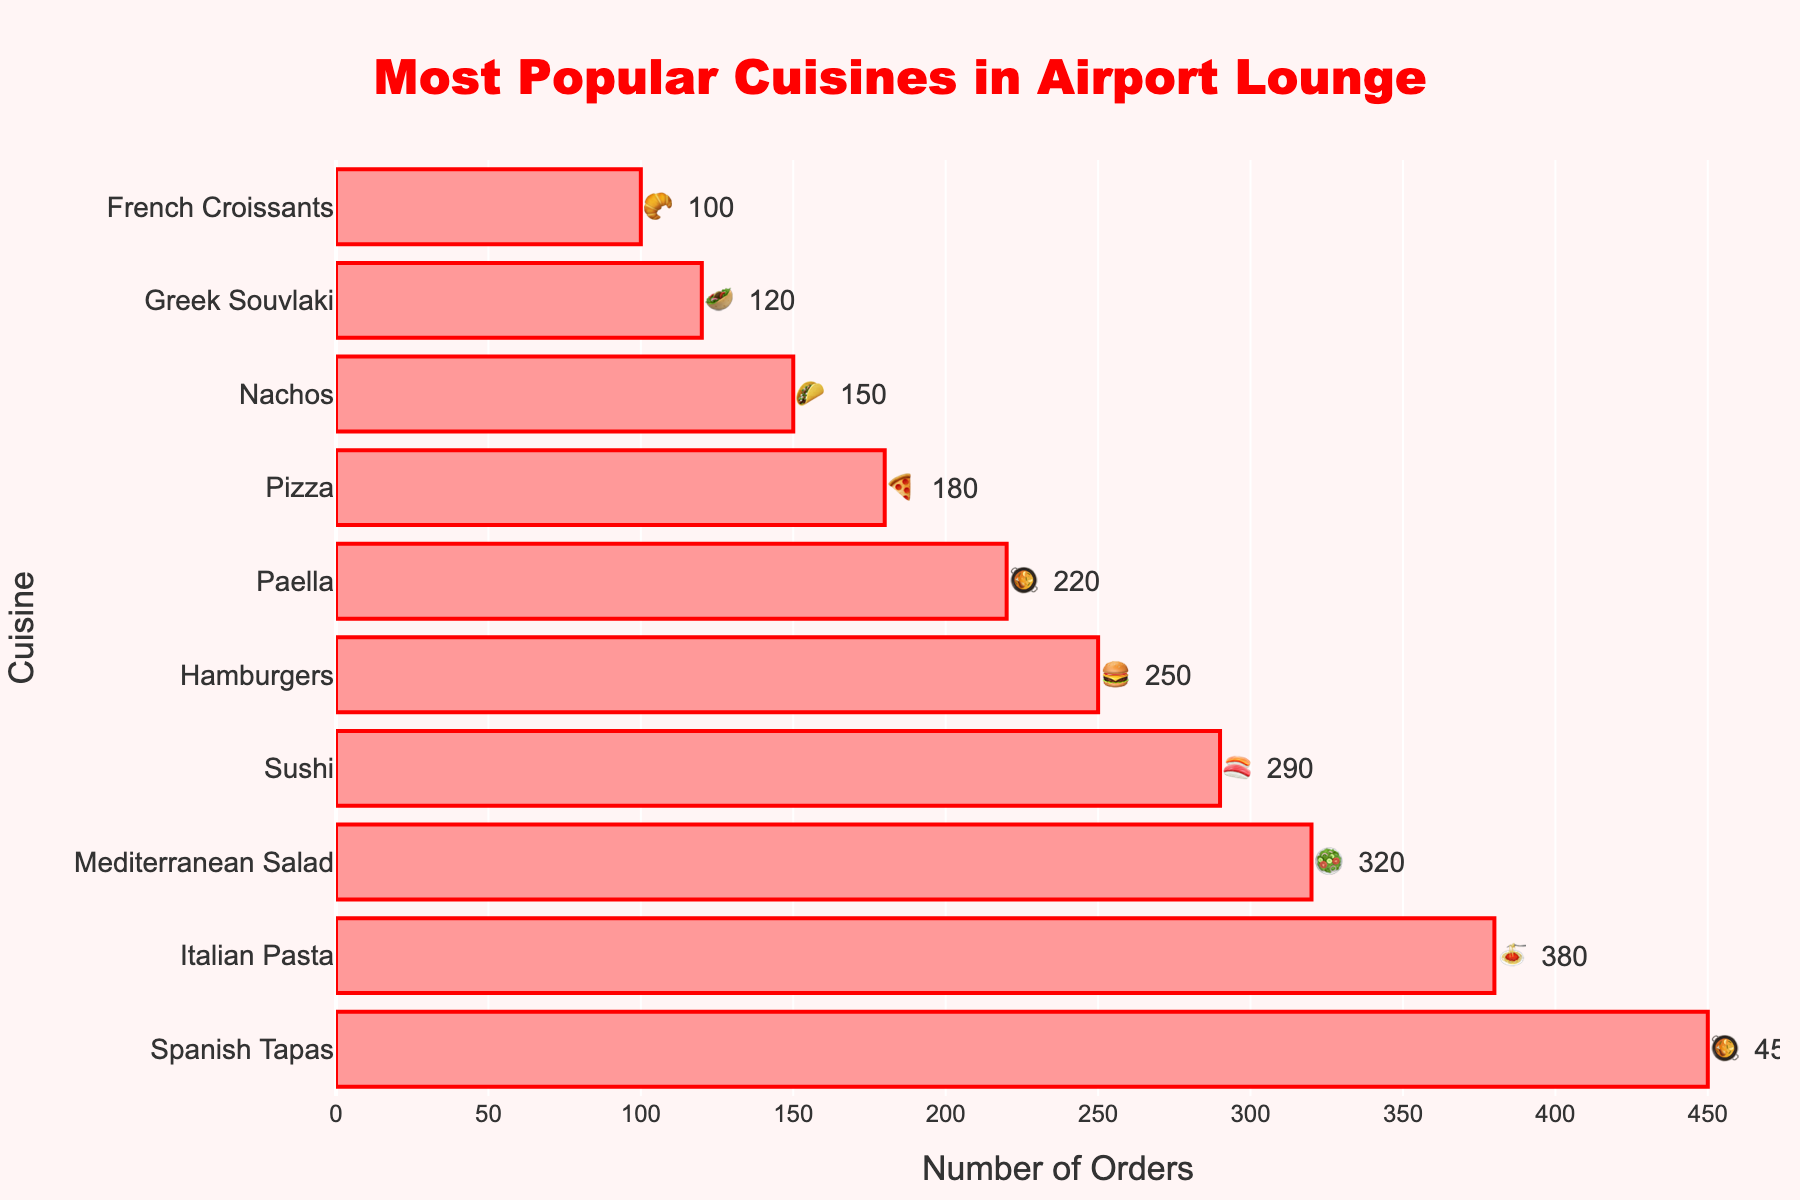What's the title of the chart? The title is displayed at the top of the chart.
Answer: Most Popular Cuisines in Airport Lounge Which cuisine is the most popular in the airport lounge? The bar with the highest value represents the most popular cuisine.
Answer: Spanish Tapas How many orders are there for Sushi? Find the bar labeled "Sushi" and read the corresponding value.
Answer: 290 What's the total number of orders of the top three cuisines? Sum the number of orders for the top three cuisines: Spanish Tapas (450), Italian Pasta (380), and Mediterranean Salad (320). 450 + 380 + 320 = 1150.
Answer: 1150 Which cuisine has more orders: Hamburgers or Pizza? Compare the values for Hamburgers (250) and Pizza (180).
Answer: Hamburgers Does Paella have more or fewer orders than Nachos? Compare the values for Paella (220) and Nachos (150).
Answer: More What is the total number of orders for all cuisines? Sum the orders of all cuisines: 450 + 380 + 320 + 290 + 250 + 220 + 180 + 150 + 120 + 100 = 2460.
Answer: 2460 How much more popular are Spanish Tapas than Greek Souvlaki? Subtract the number of orders for Greek Souvlaki (120) from the number of orders for Spanish Tapas (450). 450 - 120 = 330.
Answer: 330 Which cuisine is less popular: Nachos or French Croissants? Compare the values of Nachos (150) and French Croissants (100).
Answer: French Croissants 